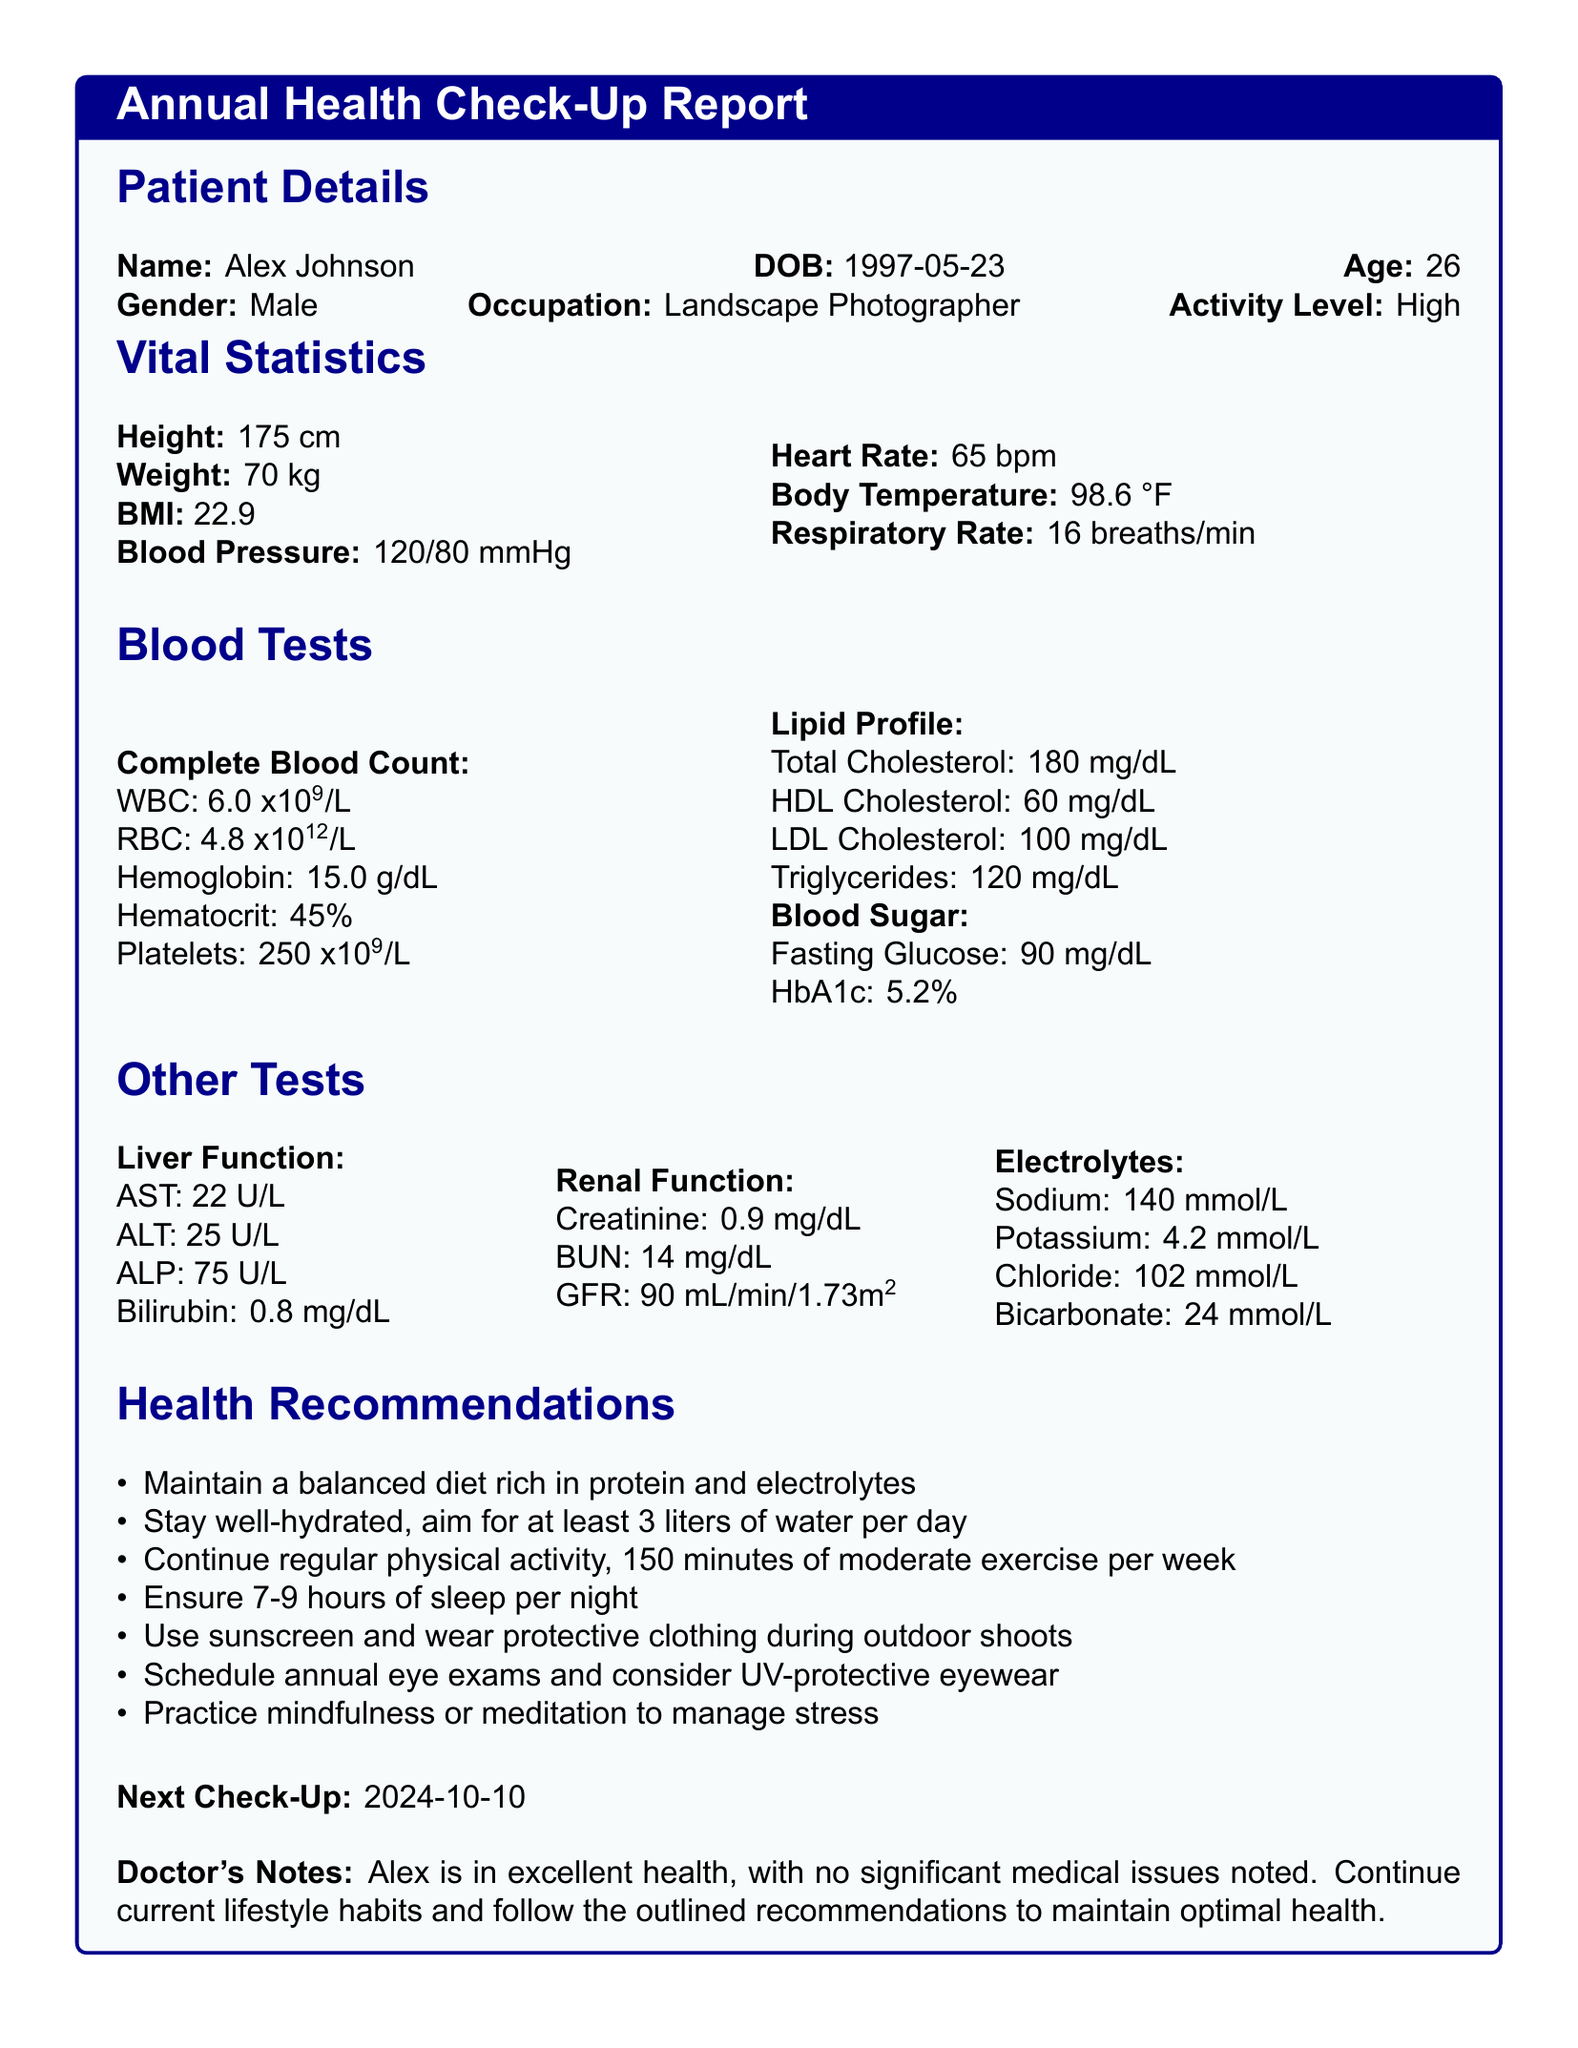what is the name of the patient? The patient's name is listed in the Patient Details section of the document.
Answer: Alex Johnson what is the age of the patient? The age of the patient is provided in the Patient Details section.
Answer: 26 what is the patient's BMI? The BMI is reported under the Vital Statistics section of the document.
Answer: 22.9 what is the fasting glucose level? The fasting glucose level can be found in the Blood Tests section, specifically under Blood Sugar.
Answer: 90 mg/dL what should the patient aim for in terms of water intake per day? This recommendation is included under Health Recommendations in the document.
Answer: at least 3 liters what is the patient's heart rate? The patient's heart rate is listed under Vital Statistics, which provides various health measurements.
Answer: 65 bpm how often should the patient schedule their check-ups? The document indicates the frequency of the check-ups explicitly.
Answer: annually what is the date of the next check-up? The next check-up date is mentioned at the end of the report.
Answer: 2024-10-10 what profession does the patient have? The occupation of the patient is noted in the Patient Details section.
Answer: Landscape Photographer 